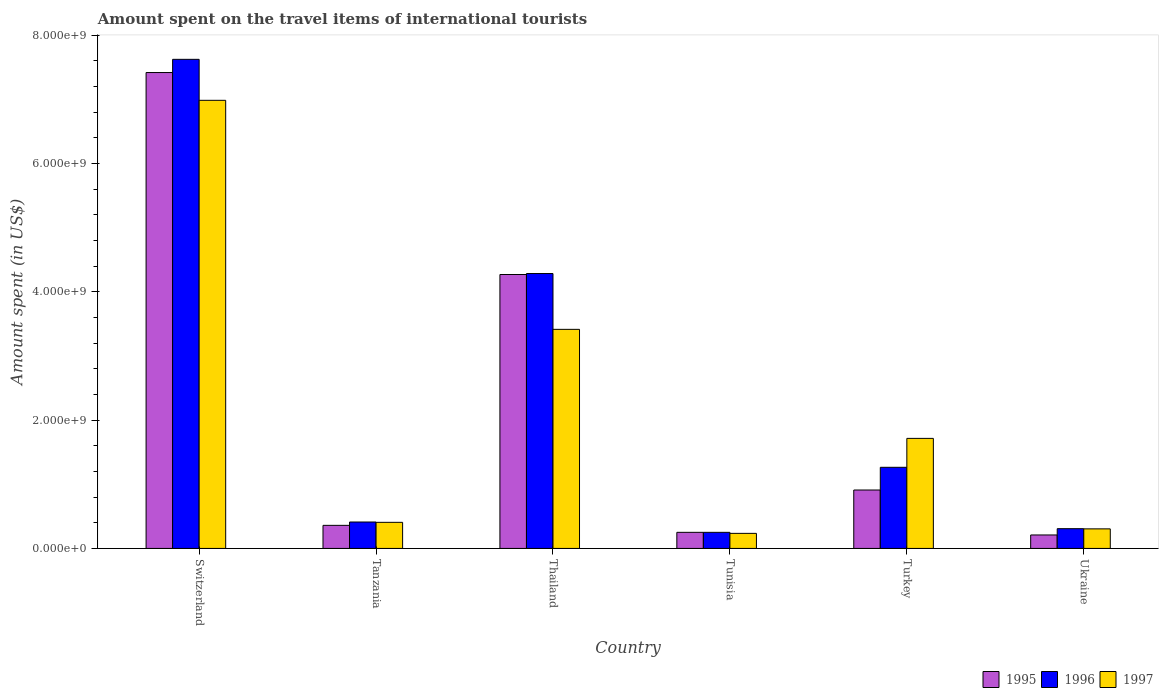How many groups of bars are there?
Keep it short and to the point. 6. Are the number of bars per tick equal to the number of legend labels?
Your response must be concise. Yes. Are the number of bars on each tick of the X-axis equal?
Your answer should be compact. Yes. How many bars are there on the 4th tick from the right?
Give a very brief answer. 3. What is the label of the 2nd group of bars from the left?
Your answer should be very brief. Tanzania. In how many cases, is the number of bars for a given country not equal to the number of legend labels?
Your response must be concise. 0. What is the amount spent on the travel items of international tourists in 1996 in Switzerland?
Ensure brevity in your answer.  7.63e+09. Across all countries, what is the maximum amount spent on the travel items of international tourists in 1995?
Offer a terse response. 7.42e+09. Across all countries, what is the minimum amount spent on the travel items of international tourists in 1996?
Your response must be concise. 2.51e+08. In which country was the amount spent on the travel items of international tourists in 1997 maximum?
Make the answer very short. Switzerland. In which country was the amount spent on the travel items of international tourists in 1997 minimum?
Provide a short and direct response. Tunisia. What is the total amount spent on the travel items of international tourists in 1997 in the graph?
Keep it short and to the point. 1.31e+1. What is the difference between the amount spent on the travel items of international tourists in 1996 in Switzerland and that in Thailand?
Keep it short and to the point. 3.34e+09. What is the difference between the amount spent on the travel items of international tourists in 1995 in Switzerland and the amount spent on the travel items of international tourists in 1996 in Ukraine?
Ensure brevity in your answer.  7.11e+09. What is the average amount spent on the travel items of international tourists in 1996 per country?
Provide a short and direct response. 2.36e+09. What is the difference between the amount spent on the travel items of international tourists of/in 1997 and amount spent on the travel items of international tourists of/in 1995 in Turkey?
Offer a very short reply. 8.05e+08. What is the ratio of the amount spent on the travel items of international tourists in 1996 in Switzerland to that in Ukraine?
Your response must be concise. 24.76. Is the amount spent on the travel items of international tourists in 1997 in Turkey less than that in Ukraine?
Offer a very short reply. No. Is the difference between the amount spent on the travel items of international tourists in 1997 in Tanzania and Tunisia greater than the difference between the amount spent on the travel items of international tourists in 1995 in Tanzania and Tunisia?
Offer a terse response. Yes. What is the difference between the highest and the second highest amount spent on the travel items of international tourists in 1995?
Your answer should be very brief. 6.51e+09. What is the difference between the highest and the lowest amount spent on the travel items of international tourists in 1997?
Your answer should be very brief. 6.75e+09. What does the 1st bar from the left in Tanzania represents?
Give a very brief answer. 1995. Is it the case that in every country, the sum of the amount spent on the travel items of international tourists in 1997 and amount spent on the travel items of international tourists in 1995 is greater than the amount spent on the travel items of international tourists in 1996?
Make the answer very short. Yes. How many bars are there?
Offer a very short reply. 18. What is the difference between two consecutive major ticks on the Y-axis?
Your response must be concise. 2.00e+09. Are the values on the major ticks of Y-axis written in scientific E-notation?
Keep it short and to the point. Yes. Where does the legend appear in the graph?
Provide a short and direct response. Bottom right. How are the legend labels stacked?
Ensure brevity in your answer.  Horizontal. What is the title of the graph?
Your answer should be very brief. Amount spent on the travel items of international tourists. Does "1985" appear as one of the legend labels in the graph?
Provide a succinct answer. No. What is the label or title of the X-axis?
Your answer should be compact. Country. What is the label or title of the Y-axis?
Keep it short and to the point. Amount spent (in US$). What is the Amount spent (in US$) of 1995 in Switzerland?
Your response must be concise. 7.42e+09. What is the Amount spent (in US$) of 1996 in Switzerland?
Offer a very short reply. 7.63e+09. What is the Amount spent (in US$) of 1997 in Switzerland?
Provide a short and direct response. 6.99e+09. What is the Amount spent (in US$) of 1995 in Tanzania?
Offer a very short reply. 3.60e+08. What is the Amount spent (in US$) of 1996 in Tanzania?
Your answer should be compact. 4.12e+08. What is the Amount spent (in US$) of 1997 in Tanzania?
Your answer should be compact. 4.07e+08. What is the Amount spent (in US$) in 1995 in Thailand?
Give a very brief answer. 4.27e+09. What is the Amount spent (in US$) in 1996 in Thailand?
Ensure brevity in your answer.  4.29e+09. What is the Amount spent (in US$) of 1997 in Thailand?
Offer a terse response. 3.42e+09. What is the Amount spent (in US$) of 1995 in Tunisia?
Ensure brevity in your answer.  2.51e+08. What is the Amount spent (in US$) in 1996 in Tunisia?
Make the answer very short. 2.51e+08. What is the Amount spent (in US$) of 1997 in Tunisia?
Your answer should be very brief. 2.35e+08. What is the Amount spent (in US$) of 1995 in Turkey?
Keep it short and to the point. 9.11e+08. What is the Amount spent (in US$) of 1996 in Turkey?
Your answer should be compact. 1.26e+09. What is the Amount spent (in US$) of 1997 in Turkey?
Give a very brief answer. 1.72e+09. What is the Amount spent (in US$) in 1995 in Ukraine?
Your answer should be very brief. 2.10e+08. What is the Amount spent (in US$) of 1996 in Ukraine?
Provide a succinct answer. 3.08e+08. What is the Amount spent (in US$) in 1997 in Ukraine?
Provide a short and direct response. 3.05e+08. Across all countries, what is the maximum Amount spent (in US$) of 1995?
Your answer should be compact. 7.42e+09. Across all countries, what is the maximum Amount spent (in US$) of 1996?
Ensure brevity in your answer.  7.63e+09. Across all countries, what is the maximum Amount spent (in US$) of 1997?
Give a very brief answer. 6.99e+09. Across all countries, what is the minimum Amount spent (in US$) in 1995?
Ensure brevity in your answer.  2.10e+08. Across all countries, what is the minimum Amount spent (in US$) of 1996?
Keep it short and to the point. 2.51e+08. Across all countries, what is the minimum Amount spent (in US$) of 1997?
Make the answer very short. 2.35e+08. What is the total Amount spent (in US$) in 1995 in the graph?
Keep it short and to the point. 1.34e+1. What is the total Amount spent (in US$) of 1996 in the graph?
Ensure brevity in your answer.  1.41e+1. What is the total Amount spent (in US$) in 1997 in the graph?
Your answer should be compact. 1.31e+1. What is the difference between the Amount spent (in US$) in 1995 in Switzerland and that in Tanzania?
Give a very brief answer. 7.06e+09. What is the difference between the Amount spent (in US$) of 1996 in Switzerland and that in Tanzania?
Offer a terse response. 7.21e+09. What is the difference between the Amount spent (in US$) of 1997 in Switzerland and that in Tanzania?
Keep it short and to the point. 6.58e+09. What is the difference between the Amount spent (in US$) in 1995 in Switzerland and that in Thailand?
Offer a very short reply. 3.15e+09. What is the difference between the Amount spent (in US$) in 1996 in Switzerland and that in Thailand?
Keep it short and to the point. 3.34e+09. What is the difference between the Amount spent (in US$) of 1997 in Switzerland and that in Thailand?
Offer a terse response. 3.57e+09. What is the difference between the Amount spent (in US$) in 1995 in Switzerland and that in Tunisia?
Keep it short and to the point. 7.17e+09. What is the difference between the Amount spent (in US$) of 1996 in Switzerland and that in Tunisia?
Your response must be concise. 7.38e+09. What is the difference between the Amount spent (in US$) in 1997 in Switzerland and that in Tunisia?
Provide a succinct answer. 6.75e+09. What is the difference between the Amount spent (in US$) of 1995 in Switzerland and that in Turkey?
Ensure brevity in your answer.  6.51e+09. What is the difference between the Amount spent (in US$) in 1996 in Switzerland and that in Turkey?
Provide a succinct answer. 6.36e+09. What is the difference between the Amount spent (in US$) in 1997 in Switzerland and that in Turkey?
Your answer should be compact. 5.27e+09. What is the difference between the Amount spent (in US$) in 1995 in Switzerland and that in Ukraine?
Give a very brief answer. 7.21e+09. What is the difference between the Amount spent (in US$) in 1996 in Switzerland and that in Ukraine?
Provide a succinct answer. 7.32e+09. What is the difference between the Amount spent (in US$) in 1997 in Switzerland and that in Ukraine?
Your answer should be compact. 6.68e+09. What is the difference between the Amount spent (in US$) of 1995 in Tanzania and that in Thailand?
Make the answer very short. -3.91e+09. What is the difference between the Amount spent (in US$) in 1996 in Tanzania and that in Thailand?
Keep it short and to the point. -3.87e+09. What is the difference between the Amount spent (in US$) in 1997 in Tanzania and that in Thailand?
Your response must be concise. -3.01e+09. What is the difference between the Amount spent (in US$) in 1995 in Tanzania and that in Tunisia?
Offer a very short reply. 1.09e+08. What is the difference between the Amount spent (in US$) in 1996 in Tanzania and that in Tunisia?
Your response must be concise. 1.61e+08. What is the difference between the Amount spent (in US$) in 1997 in Tanzania and that in Tunisia?
Ensure brevity in your answer.  1.72e+08. What is the difference between the Amount spent (in US$) in 1995 in Tanzania and that in Turkey?
Your response must be concise. -5.51e+08. What is the difference between the Amount spent (in US$) in 1996 in Tanzania and that in Turkey?
Your response must be concise. -8.53e+08. What is the difference between the Amount spent (in US$) of 1997 in Tanzania and that in Turkey?
Make the answer very short. -1.31e+09. What is the difference between the Amount spent (in US$) in 1995 in Tanzania and that in Ukraine?
Provide a succinct answer. 1.50e+08. What is the difference between the Amount spent (in US$) in 1996 in Tanzania and that in Ukraine?
Provide a short and direct response. 1.04e+08. What is the difference between the Amount spent (in US$) of 1997 in Tanzania and that in Ukraine?
Your response must be concise. 1.02e+08. What is the difference between the Amount spent (in US$) in 1995 in Thailand and that in Tunisia?
Provide a short and direct response. 4.02e+09. What is the difference between the Amount spent (in US$) in 1996 in Thailand and that in Tunisia?
Provide a short and direct response. 4.04e+09. What is the difference between the Amount spent (in US$) of 1997 in Thailand and that in Tunisia?
Offer a terse response. 3.18e+09. What is the difference between the Amount spent (in US$) of 1995 in Thailand and that in Turkey?
Keep it short and to the point. 3.36e+09. What is the difference between the Amount spent (in US$) in 1996 in Thailand and that in Turkey?
Keep it short and to the point. 3.02e+09. What is the difference between the Amount spent (in US$) in 1997 in Thailand and that in Turkey?
Your answer should be very brief. 1.70e+09. What is the difference between the Amount spent (in US$) in 1995 in Thailand and that in Ukraine?
Offer a terse response. 4.06e+09. What is the difference between the Amount spent (in US$) of 1996 in Thailand and that in Ukraine?
Give a very brief answer. 3.98e+09. What is the difference between the Amount spent (in US$) of 1997 in Thailand and that in Ukraine?
Offer a very short reply. 3.11e+09. What is the difference between the Amount spent (in US$) of 1995 in Tunisia and that in Turkey?
Offer a very short reply. -6.60e+08. What is the difference between the Amount spent (in US$) of 1996 in Tunisia and that in Turkey?
Your response must be concise. -1.01e+09. What is the difference between the Amount spent (in US$) of 1997 in Tunisia and that in Turkey?
Give a very brief answer. -1.48e+09. What is the difference between the Amount spent (in US$) in 1995 in Tunisia and that in Ukraine?
Your answer should be compact. 4.10e+07. What is the difference between the Amount spent (in US$) in 1996 in Tunisia and that in Ukraine?
Your answer should be compact. -5.70e+07. What is the difference between the Amount spent (in US$) of 1997 in Tunisia and that in Ukraine?
Provide a succinct answer. -7.00e+07. What is the difference between the Amount spent (in US$) of 1995 in Turkey and that in Ukraine?
Offer a terse response. 7.01e+08. What is the difference between the Amount spent (in US$) in 1996 in Turkey and that in Ukraine?
Keep it short and to the point. 9.57e+08. What is the difference between the Amount spent (in US$) of 1997 in Turkey and that in Ukraine?
Provide a short and direct response. 1.41e+09. What is the difference between the Amount spent (in US$) of 1995 in Switzerland and the Amount spent (in US$) of 1996 in Tanzania?
Make the answer very short. 7.01e+09. What is the difference between the Amount spent (in US$) in 1995 in Switzerland and the Amount spent (in US$) in 1997 in Tanzania?
Offer a very short reply. 7.01e+09. What is the difference between the Amount spent (in US$) in 1996 in Switzerland and the Amount spent (in US$) in 1997 in Tanzania?
Provide a succinct answer. 7.22e+09. What is the difference between the Amount spent (in US$) of 1995 in Switzerland and the Amount spent (in US$) of 1996 in Thailand?
Your answer should be compact. 3.13e+09. What is the difference between the Amount spent (in US$) of 1995 in Switzerland and the Amount spent (in US$) of 1997 in Thailand?
Offer a terse response. 4.00e+09. What is the difference between the Amount spent (in US$) in 1996 in Switzerland and the Amount spent (in US$) in 1997 in Thailand?
Provide a short and direct response. 4.21e+09. What is the difference between the Amount spent (in US$) of 1995 in Switzerland and the Amount spent (in US$) of 1996 in Tunisia?
Your answer should be very brief. 7.17e+09. What is the difference between the Amount spent (in US$) in 1995 in Switzerland and the Amount spent (in US$) in 1997 in Tunisia?
Make the answer very short. 7.18e+09. What is the difference between the Amount spent (in US$) of 1996 in Switzerland and the Amount spent (in US$) of 1997 in Tunisia?
Offer a very short reply. 7.39e+09. What is the difference between the Amount spent (in US$) of 1995 in Switzerland and the Amount spent (in US$) of 1996 in Turkey?
Your response must be concise. 6.16e+09. What is the difference between the Amount spent (in US$) of 1995 in Switzerland and the Amount spent (in US$) of 1997 in Turkey?
Offer a terse response. 5.70e+09. What is the difference between the Amount spent (in US$) of 1996 in Switzerland and the Amount spent (in US$) of 1997 in Turkey?
Provide a short and direct response. 5.91e+09. What is the difference between the Amount spent (in US$) of 1995 in Switzerland and the Amount spent (in US$) of 1996 in Ukraine?
Offer a very short reply. 7.11e+09. What is the difference between the Amount spent (in US$) in 1995 in Switzerland and the Amount spent (in US$) in 1997 in Ukraine?
Ensure brevity in your answer.  7.12e+09. What is the difference between the Amount spent (in US$) of 1996 in Switzerland and the Amount spent (in US$) of 1997 in Ukraine?
Offer a terse response. 7.32e+09. What is the difference between the Amount spent (in US$) in 1995 in Tanzania and the Amount spent (in US$) in 1996 in Thailand?
Your answer should be compact. -3.93e+09. What is the difference between the Amount spent (in US$) of 1995 in Tanzania and the Amount spent (in US$) of 1997 in Thailand?
Provide a succinct answer. -3.06e+09. What is the difference between the Amount spent (in US$) of 1996 in Tanzania and the Amount spent (in US$) of 1997 in Thailand?
Your answer should be compact. -3.00e+09. What is the difference between the Amount spent (in US$) of 1995 in Tanzania and the Amount spent (in US$) of 1996 in Tunisia?
Offer a terse response. 1.09e+08. What is the difference between the Amount spent (in US$) of 1995 in Tanzania and the Amount spent (in US$) of 1997 in Tunisia?
Give a very brief answer. 1.25e+08. What is the difference between the Amount spent (in US$) in 1996 in Tanzania and the Amount spent (in US$) in 1997 in Tunisia?
Your answer should be compact. 1.77e+08. What is the difference between the Amount spent (in US$) of 1995 in Tanzania and the Amount spent (in US$) of 1996 in Turkey?
Offer a terse response. -9.05e+08. What is the difference between the Amount spent (in US$) of 1995 in Tanzania and the Amount spent (in US$) of 1997 in Turkey?
Your answer should be very brief. -1.36e+09. What is the difference between the Amount spent (in US$) of 1996 in Tanzania and the Amount spent (in US$) of 1997 in Turkey?
Provide a succinct answer. -1.30e+09. What is the difference between the Amount spent (in US$) in 1995 in Tanzania and the Amount spent (in US$) in 1996 in Ukraine?
Provide a succinct answer. 5.20e+07. What is the difference between the Amount spent (in US$) in 1995 in Tanzania and the Amount spent (in US$) in 1997 in Ukraine?
Offer a terse response. 5.50e+07. What is the difference between the Amount spent (in US$) of 1996 in Tanzania and the Amount spent (in US$) of 1997 in Ukraine?
Offer a terse response. 1.07e+08. What is the difference between the Amount spent (in US$) of 1995 in Thailand and the Amount spent (in US$) of 1996 in Tunisia?
Ensure brevity in your answer.  4.02e+09. What is the difference between the Amount spent (in US$) of 1995 in Thailand and the Amount spent (in US$) of 1997 in Tunisia?
Ensure brevity in your answer.  4.04e+09. What is the difference between the Amount spent (in US$) of 1996 in Thailand and the Amount spent (in US$) of 1997 in Tunisia?
Provide a succinct answer. 4.05e+09. What is the difference between the Amount spent (in US$) of 1995 in Thailand and the Amount spent (in US$) of 1996 in Turkey?
Provide a short and direct response. 3.01e+09. What is the difference between the Amount spent (in US$) of 1995 in Thailand and the Amount spent (in US$) of 1997 in Turkey?
Your answer should be very brief. 2.56e+09. What is the difference between the Amount spent (in US$) in 1996 in Thailand and the Amount spent (in US$) in 1997 in Turkey?
Your response must be concise. 2.57e+09. What is the difference between the Amount spent (in US$) in 1995 in Thailand and the Amount spent (in US$) in 1996 in Ukraine?
Offer a terse response. 3.96e+09. What is the difference between the Amount spent (in US$) in 1995 in Thailand and the Amount spent (in US$) in 1997 in Ukraine?
Your answer should be compact. 3.97e+09. What is the difference between the Amount spent (in US$) of 1996 in Thailand and the Amount spent (in US$) of 1997 in Ukraine?
Your answer should be compact. 3.98e+09. What is the difference between the Amount spent (in US$) of 1995 in Tunisia and the Amount spent (in US$) of 1996 in Turkey?
Provide a short and direct response. -1.01e+09. What is the difference between the Amount spent (in US$) in 1995 in Tunisia and the Amount spent (in US$) in 1997 in Turkey?
Your answer should be very brief. -1.46e+09. What is the difference between the Amount spent (in US$) in 1996 in Tunisia and the Amount spent (in US$) in 1997 in Turkey?
Your response must be concise. -1.46e+09. What is the difference between the Amount spent (in US$) in 1995 in Tunisia and the Amount spent (in US$) in 1996 in Ukraine?
Make the answer very short. -5.70e+07. What is the difference between the Amount spent (in US$) in 1995 in Tunisia and the Amount spent (in US$) in 1997 in Ukraine?
Provide a succinct answer. -5.40e+07. What is the difference between the Amount spent (in US$) of 1996 in Tunisia and the Amount spent (in US$) of 1997 in Ukraine?
Offer a terse response. -5.40e+07. What is the difference between the Amount spent (in US$) of 1995 in Turkey and the Amount spent (in US$) of 1996 in Ukraine?
Keep it short and to the point. 6.03e+08. What is the difference between the Amount spent (in US$) of 1995 in Turkey and the Amount spent (in US$) of 1997 in Ukraine?
Provide a short and direct response. 6.06e+08. What is the difference between the Amount spent (in US$) in 1996 in Turkey and the Amount spent (in US$) in 1997 in Ukraine?
Your answer should be compact. 9.60e+08. What is the average Amount spent (in US$) in 1995 per country?
Offer a terse response. 2.24e+09. What is the average Amount spent (in US$) of 1996 per country?
Your answer should be compact. 2.36e+09. What is the average Amount spent (in US$) in 1997 per country?
Provide a succinct answer. 2.18e+09. What is the difference between the Amount spent (in US$) in 1995 and Amount spent (in US$) in 1996 in Switzerland?
Give a very brief answer. -2.06e+08. What is the difference between the Amount spent (in US$) of 1995 and Amount spent (in US$) of 1997 in Switzerland?
Keep it short and to the point. 4.33e+08. What is the difference between the Amount spent (in US$) of 1996 and Amount spent (in US$) of 1997 in Switzerland?
Provide a succinct answer. 6.39e+08. What is the difference between the Amount spent (in US$) in 1995 and Amount spent (in US$) in 1996 in Tanzania?
Offer a terse response. -5.20e+07. What is the difference between the Amount spent (in US$) of 1995 and Amount spent (in US$) of 1997 in Tanzania?
Offer a very short reply. -4.70e+07. What is the difference between the Amount spent (in US$) in 1996 and Amount spent (in US$) in 1997 in Tanzania?
Your answer should be very brief. 5.00e+06. What is the difference between the Amount spent (in US$) of 1995 and Amount spent (in US$) of 1996 in Thailand?
Make the answer very short. -1.50e+07. What is the difference between the Amount spent (in US$) in 1995 and Amount spent (in US$) in 1997 in Thailand?
Keep it short and to the point. 8.55e+08. What is the difference between the Amount spent (in US$) of 1996 and Amount spent (in US$) of 1997 in Thailand?
Offer a very short reply. 8.70e+08. What is the difference between the Amount spent (in US$) in 1995 and Amount spent (in US$) in 1997 in Tunisia?
Offer a terse response. 1.60e+07. What is the difference between the Amount spent (in US$) in 1996 and Amount spent (in US$) in 1997 in Tunisia?
Ensure brevity in your answer.  1.60e+07. What is the difference between the Amount spent (in US$) of 1995 and Amount spent (in US$) of 1996 in Turkey?
Your response must be concise. -3.54e+08. What is the difference between the Amount spent (in US$) of 1995 and Amount spent (in US$) of 1997 in Turkey?
Your answer should be compact. -8.05e+08. What is the difference between the Amount spent (in US$) of 1996 and Amount spent (in US$) of 1997 in Turkey?
Keep it short and to the point. -4.51e+08. What is the difference between the Amount spent (in US$) of 1995 and Amount spent (in US$) of 1996 in Ukraine?
Your response must be concise. -9.80e+07. What is the difference between the Amount spent (in US$) of 1995 and Amount spent (in US$) of 1997 in Ukraine?
Give a very brief answer. -9.50e+07. What is the ratio of the Amount spent (in US$) of 1995 in Switzerland to that in Tanzania?
Keep it short and to the point. 20.61. What is the ratio of the Amount spent (in US$) of 1996 in Switzerland to that in Tanzania?
Provide a short and direct response. 18.51. What is the ratio of the Amount spent (in US$) in 1997 in Switzerland to that in Tanzania?
Make the answer very short. 17.17. What is the ratio of the Amount spent (in US$) of 1995 in Switzerland to that in Thailand?
Provide a short and direct response. 1.74. What is the ratio of the Amount spent (in US$) of 1996 in Switzerland to that in Thailand?
Your answer should be compact. 1.78. What is the ratio of the Amount spent (in US$) in 1997 in Switzerland to that in Thailand?
Your answer should be compact. 2.05. What is the ratio of the Amount spent (in US$) of 1995 in Switzerland to that in Tunisia?
Your answer should be very brief. 29.56. What is the ratio of the Amount spent (in US$) of 1996 in Switzerland to that in Tunisia?
Your answer should be very brief. 30.38. What is the ratio of the Amount spent (in US$) of 1997 in Switzerland to that in Tunisia?
Give a very brief answer. 29.73. What is the ratio of the Amount spent (in US$) of 1995 in Switzerland to that in Turkey?
Offer a terse response. 8.14. What is the ratio of the Amount spent (in US$) of 1996 in Switzerland to that in Turkey?
Offer a terse response. 6.03. What is the ratio of the Amount spent (in US$) of 1997 in Switzerland to that in Turkey?
Provide a succinct answer. 4.07. What is the ratio of the Amount spent (in US$) of 1995 in Switzerland to that in Ukraine?
Ensure brevity in your answer.  35.33. What is the ratio of the Amount spent (in US$) in 1996 in Switzerland to that in Ukraine?
Provide a short and direct response. 24.76. What is the ratio of the Amount spent (in US$) of 1997 in Switzerland to that in Ukraine?
Your answer should be very brief. 22.91. What is the ratio of the Amount spent (in US$) of 1995 in Tanzania to that in Thailand?
Offer a terse response. 0.08. What is the ratio of the Amount spent (in US$) in 1996 in Tanzania to that in Thailand?
Offer a terse response. 0.1. What is the ratio of the Amount spent (in US$) in 1997 in Tanzania to that in Thailand?
Give a very brief answer. 0.12. What is the ratio of the Amount spent (in US$) of 1995 in Tanzania to that in Tunisia?
Give a very brief answer. 1.43. What is the ratio of the Amount spent (in US$) of 1996 in Tanzania to that in Tunisia?
Provide a succinct answer. 1.64. What is the ratio of the Amount spent (in US$) of 1997 in Tanzania to that in Tunisia?
Ensure brevity in your answer.  1.73. What is the ratio of the Amount spent (in US$) of 1995 in Tanzania to that in Turkey?
Keep it short and to the point. 0.4. What is the ratio of the Amount spent (in US$) in 1996 in Tanzania to that in Turkey?
Give a very brief answer. 0.33. What is the ratio of the Amount spent (in US$) in 1997 in Tanzania to that in Turkey?
Ensure brevity in your answer.  0.24. What is the ratio of the Amount spent (in US$) in 1995 in Tanzania to that in Ukraine?
Provide a short and direct response. 1.71. What is the ratio of the Amount spent (in US$) of 1996 in Tanzania to that in Ukraine?
Your answer should be compact. 1.34. What is the ratio of the Amount spent (in US$) in 1997 in Tanzania to that in Ukraine?
Ensure brevity in your answer.  1.33. What is the ratio of the Amount spent (in US$) of 1995 in Thailand to that in Tunisia?
Your response must be concise. 17.02. What is the ratio of the Amount spent (in US$) in 1996 in Thailand to that in Tunisia?
Your answer should be compact. 17.08. What is the ratio of the Amount spent (in US$) in 1997 in Thailand to that in Tunisia?
Your response must be concise. 14.54. What is the ratio of the Amount spent (in US$) of 1995 in Thailand to that in Turkey?
Give a very brief answer. 4.69. What is the ratio of the Amount spent (in US$) of 1996 in Thailand to that in Turkey?
Give a very brief answer. 3.39. What is the ratio of the Amount spent (in US$) of 1997 in Thailand to that in Turkey?
Ensure brevity in your answer.  1.99. What is the ratio of the Amount spent (in US$) of 1995 in Thailand to that in Ukraine?
Offer a very short reply. 20.34. What is the ratio of the Amount spent (in US$) in 1996 in Thailand to that in Ukraine?
Offer a terse response. 13.92. What is the ratio of the Amount spent (in US$) in 1997 in Thailand to that in Ukraine?
Keep it short and to the point. 11.2. What is the ratio of the Amount spent (in US$) in 1995 in Tunisia to that in Turkey?
Make the answer very short. 0.28. What is the ratio of the Amount spent (in US$) in 1996 in Tunisia to that in Turkey?
Your answer should be compact. 0.2. What is the ratio of the Amount spent (in US$) in 1997 in Tunisia to that in Turkey?
Offer a terse response. 0.14. What is the ratio of the Amount spent (in US$) of 1995 in Tunisia to that in Ukraine?
Make the answer very short. 1.2. What is the ratio of the Amount spent (in US$) of 1996 in Tunisia to that in Ukraine?
Offer a terse response. 0.81. What is the ratio of the Amount spent (in US$) in 1997 in Tunisia to that in Ukraine?
Provide a short and direct response. 0.77. What is the ratio of the Amount spent (in US$) of 1995 in Turkey to that in Ukraine?
Keep it short and to the point. 4.34. What is the ratio of the Amount spent (in US$) in 1996 in Turkey to that in Ukraine?
Offer a terse response. 4.11. What is the ratio of the Amount spent (in US$) of 1997 in Turkey to that in Ukraine?
Provide a short and direct response. 5.63. What is the difference between the highest and the second highest Amount spent (in US$) in 1995?
Your answer should be compact. 3.15e+09. What is the difference between the highest and the second highest Amount spent (in US$) of 1996?
Your answer should be very brief. 3.34e+09. What is the difference between the highest and the second highest Amount spent (in US$) in 1997?
Provide a short and direct response. 3.57e+09. What is the difference between the highest and the lowest Amount spent (in US$) of 1995?
Provide a short and direct response. 7.21e+09. What is the difference between the highest and the lowest Amount spent (in US$) in 1996?
Keep it short and to the point. 7.38e+09. What is the difference between the highest and the lowest Amount spent (in US$) of 1997?
Ensure brevity in your answer.  6.75e+09. 